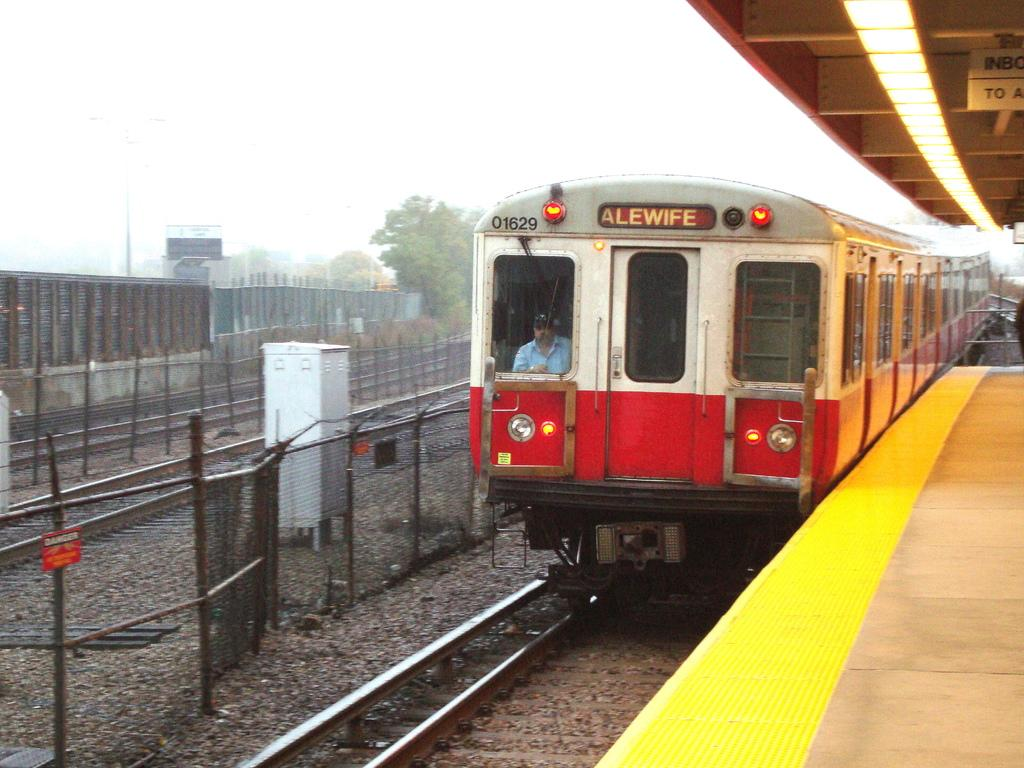<image>
Offer a succinct explanation of the picture presented. A train that is headed to Alewife has the number 01629 on it. 